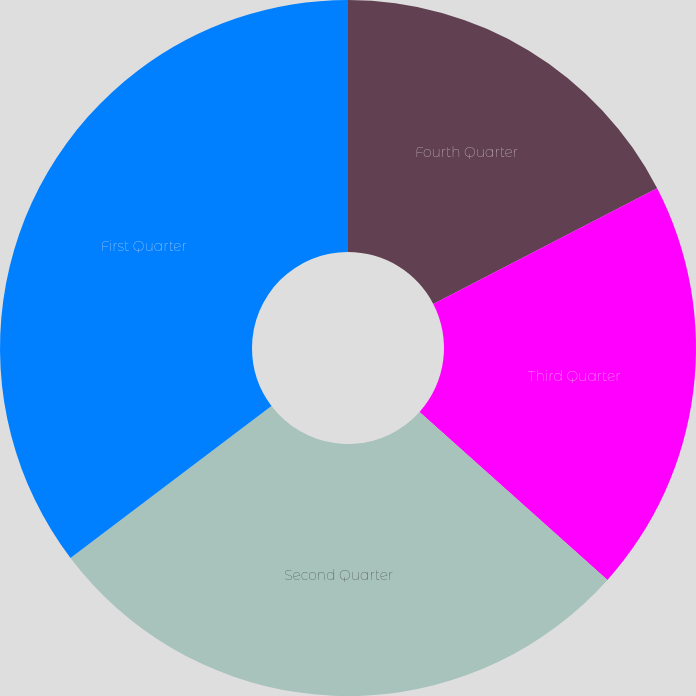<chart> <loc_0><loc_0><loc_500><loc_500><pie_chart><fcel>Fourth Quarter<fcel>Third Quarter<fcel>Second Quarter<fcel>First Quarter<nl><fcel>17.41%<fcel>19.2%<fcel>28.08%<fcel>35.31%<nl></chart> 